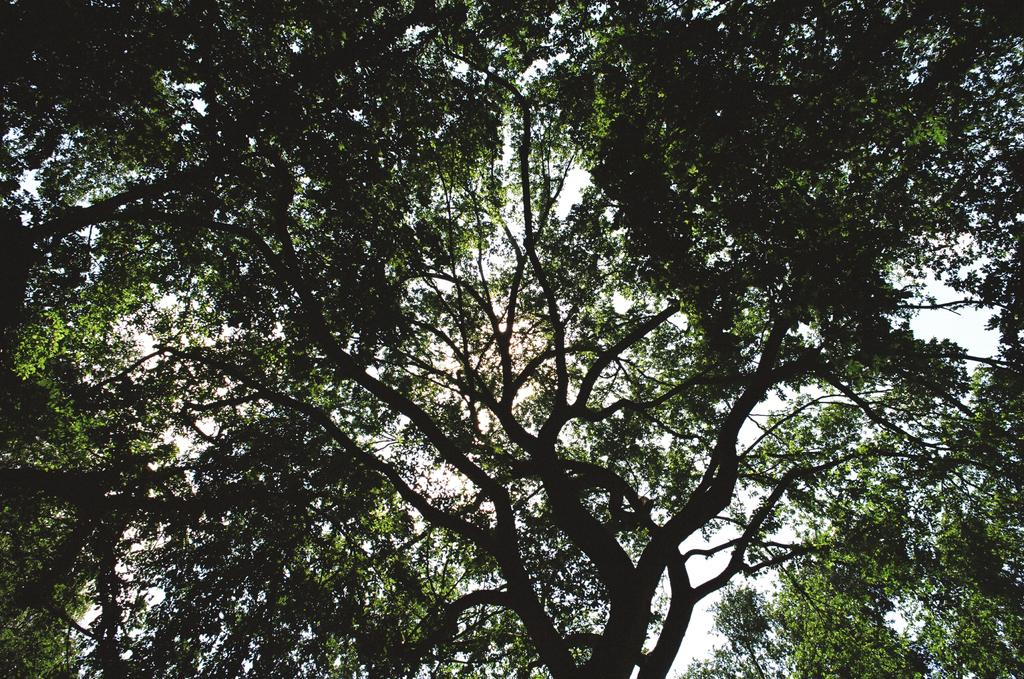What type of vegetation is present in the image? There are green color trees in the image. What can be seen in the background of the image? The sky is visible in the background of the image. What type of hammer is being used to make observations in the image? There is no hammer or observation activity present in the image. 